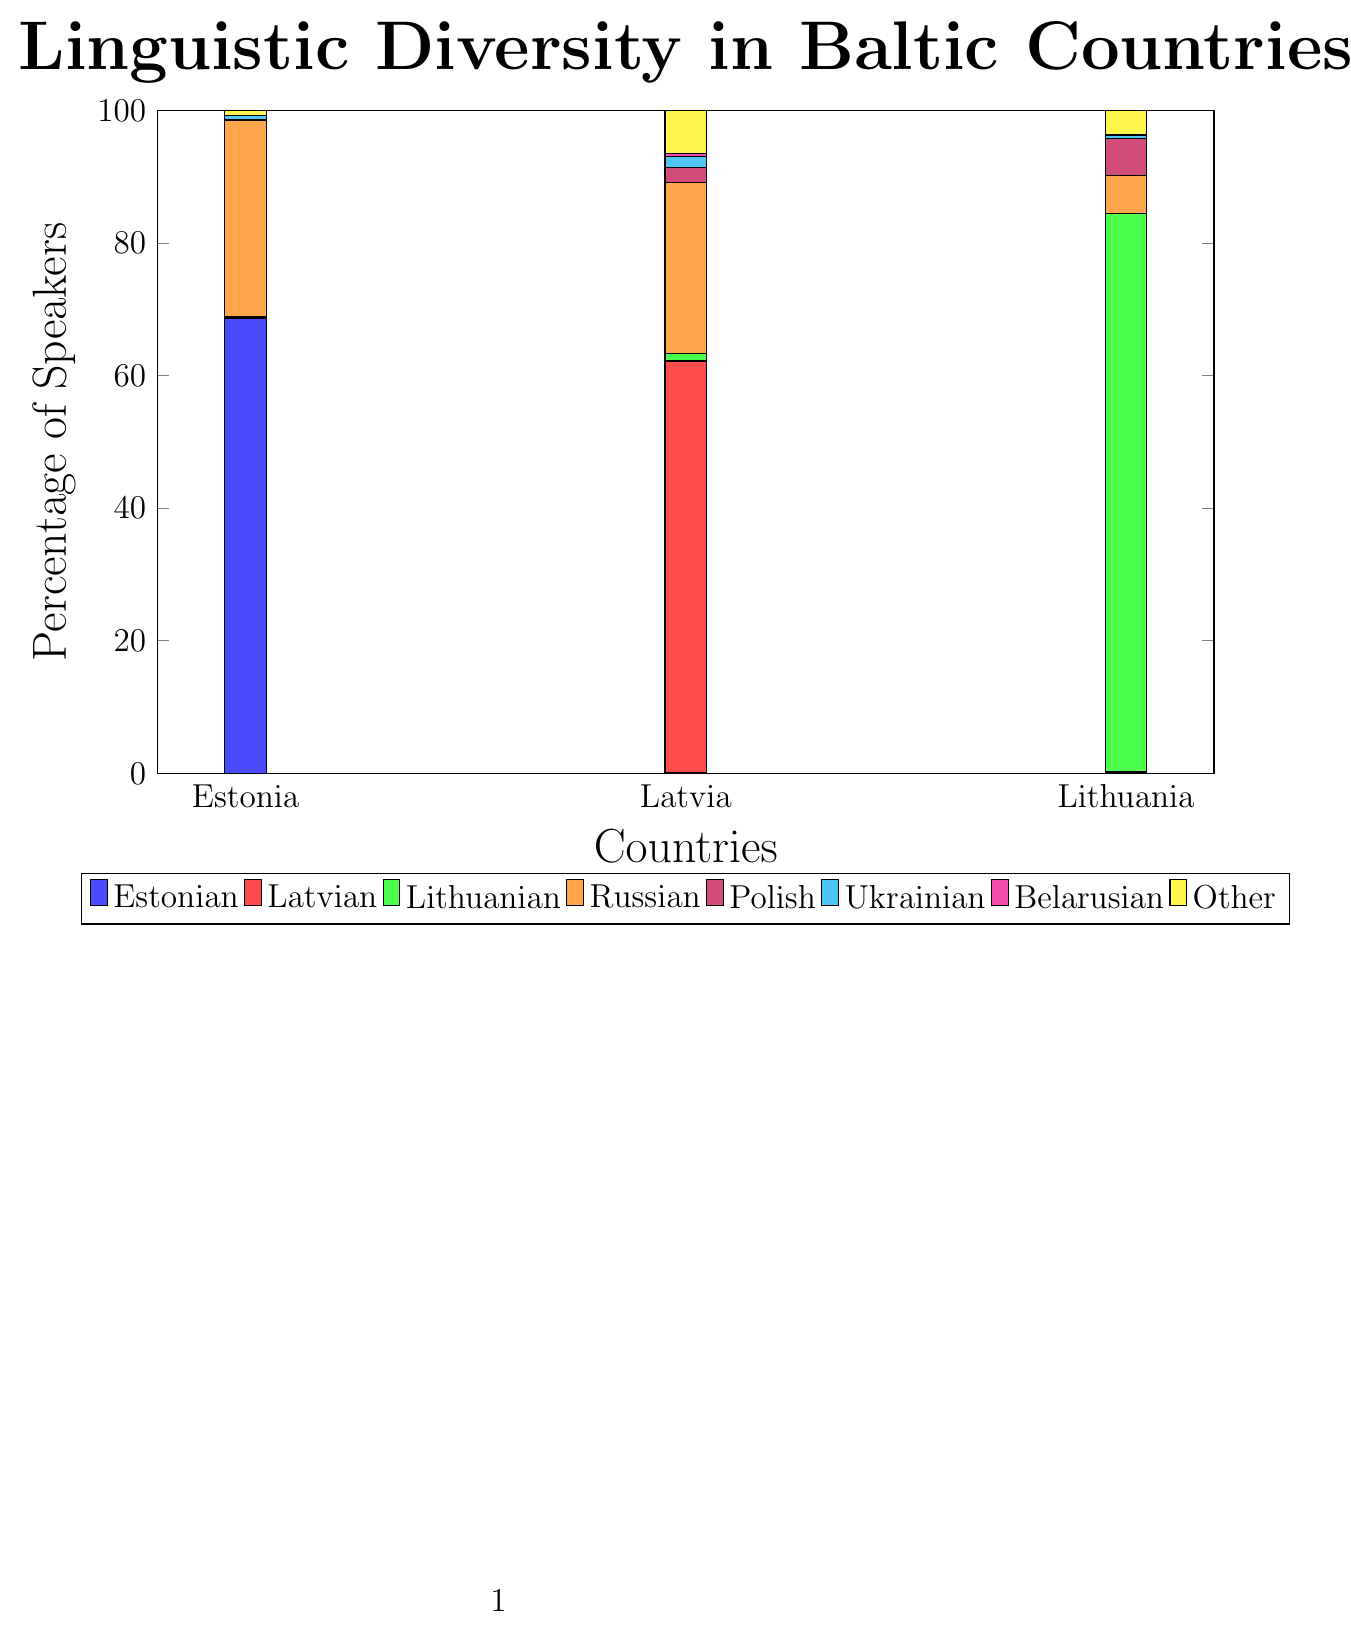Which country has the highest percentage of Estonian speakers? By looking at the bar corresponding to Estonian speakers and comparing its height across countries, we can see the highest bar under Estonia.
Answer: Estonia What is the combined percentage of Polish speakers in Latvia and Lithuania? The percentage of Polish speakers is 2.2% in Latvia and 5.6% in Lithuania. Summing these gives us 2.2 + 5.6 = 7.8%.
Answer: 7.8% Which country has a higher percentage of Russian speakers, Estonia or Lithuania? By comparing the heights of the bars for Russian speakers in Estonia and Lithuania, we see that Estonia has a higher bar at 29.6% compared to Lithuania’s 5.8%.
Answer: Estonia What is the total percentage of speakers of Latvian, Lithuanian, and Russian in Latvia? The percentages in Latvia are 62.1% for Latvian, 1.2% for Lithuanian, and 25.8% for Russian. Adding these gives 62.1 + 1.2 + 25.8 = 89.1%.
Answer: 89.1% Which country has the smallest percentage of Ukrainian speakers? By comparing the heights of the bars for Ukrainian speakers across all countries, Lithuania has the smallest bar at 0.5%.
Answer: Lithuania What is the average percentage of Belarusian speakers across all countries? The percentages of Belarusian speakers are 0.1% in Estonia, 0.4% in Latvia, and 0.1% in Lithuania. The average is calculated as (0.1 + 0.4 + 0.1) / 3 = 0.2%.
Answer: 0.2% Which country has the highest percentage of 'Other' language speakers, and what is that percentage? By comparing the heights of the bars for the 'Other' language speakers across countries, Latvia has the highest bar at 6.5%.
Answer: Latvia, 6.5% How does the percentage of Lithuanian speakers in Lithuania compare to the percentage of Latvian speakers in Latvia? By looking at the bars for Lithuanian speakers in Lithuania (84.2%) and Latvian speakers in Latvia (62.1%), we see that Lithuania has a higher percentage of its national language speakers.
Answer: Lithuania has a higher percentage What is the difference between the percentage of Russian speakers in Estonia and in Latvia? The percentage of Russian speakers is 29.6% in Estonia and 25.8% in Latvia. The difference is calculated as 29.6 - 25.8 = 3.8%.
Answer: 3.8% Which country shows a more diverse linguistic landscape based on the 'Other' category, and how is it visually indicated? By looking at the heights of the 'Other' bars, Latvia has the highest at 6.5%, indicating a more diverse linguistic landscape. This is visually indicated by the tallest bar in the 'Other' category for Latvia.
Answer: Latvia 